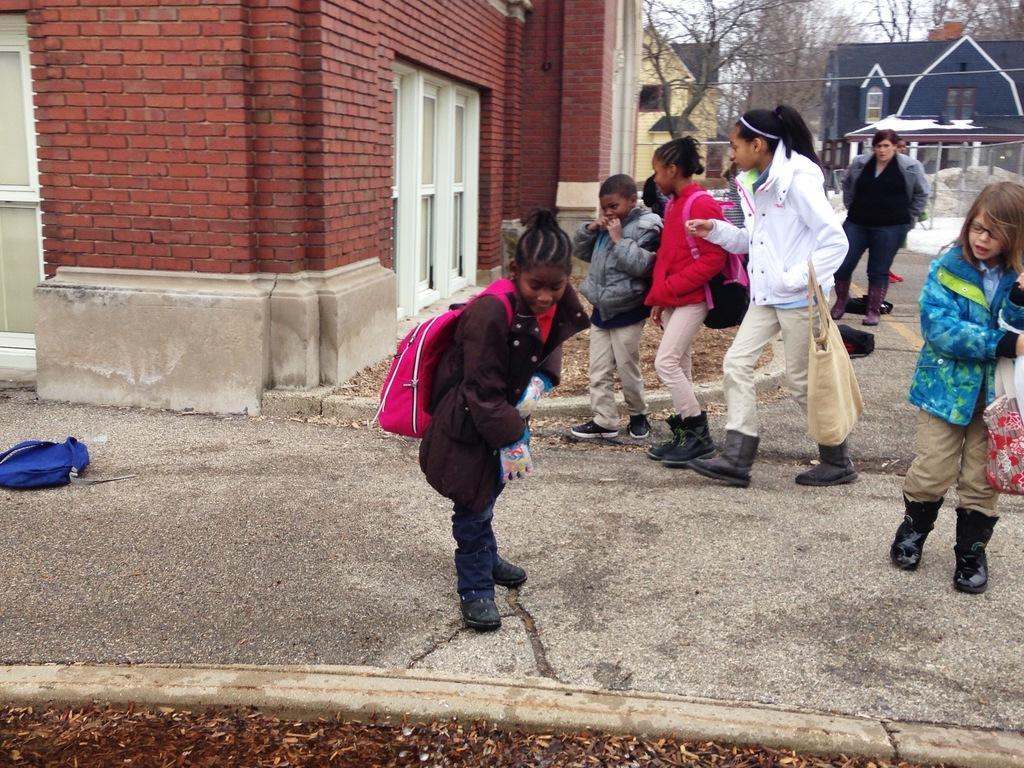Please provide a concise description of this image. There are children in the center of the image and there is a bag on the floor on the left side, there is a man in the background area and there are houses and trees in the background area. 